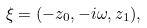Convert formula to latex. <formula><loc_0><loc_0><loc_500><loc_500>\xi = ( - z _ { 0 } , - i \omega , z _ { 1 } ) ,</formula> 